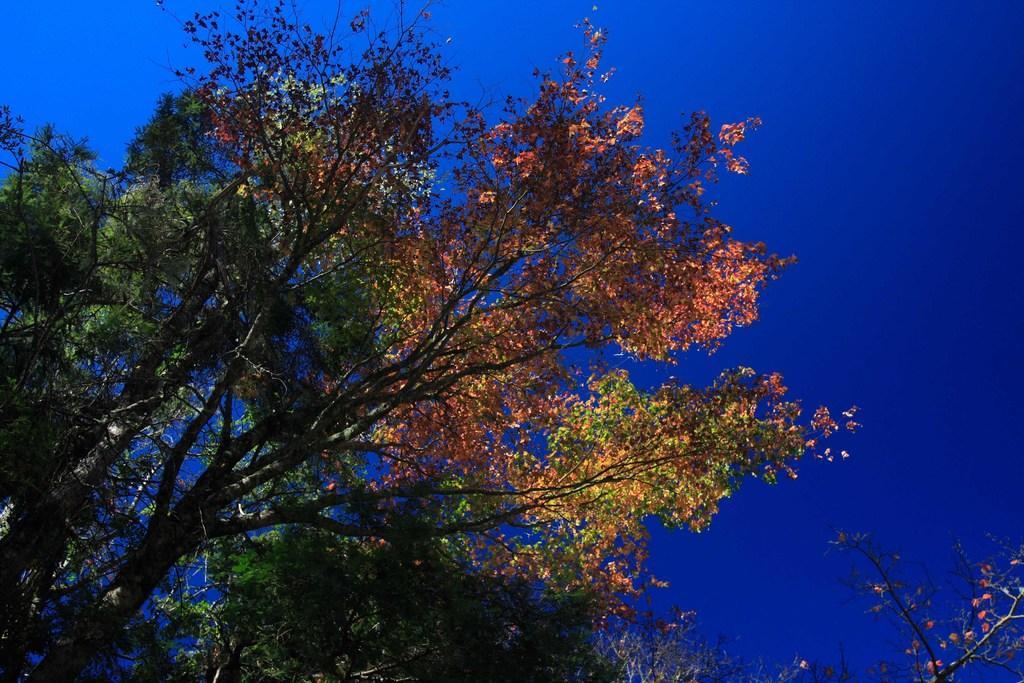Could you give a brief overview of what you see in this image? In this picture we can see there are trees and the sky. 